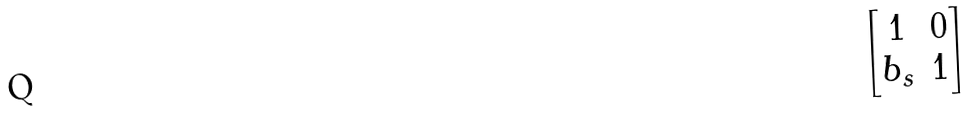<formula> <loc_0><loc_0><loc_500><loc_500>\begin{bmatrix} 1 & 0 \\ b _ { s } & 1 \end{bmatrix}</formula> 